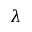Convert formula to latex. <formula><loc_0><loc_0><loc_500><loc_500>\lambda</formula> 